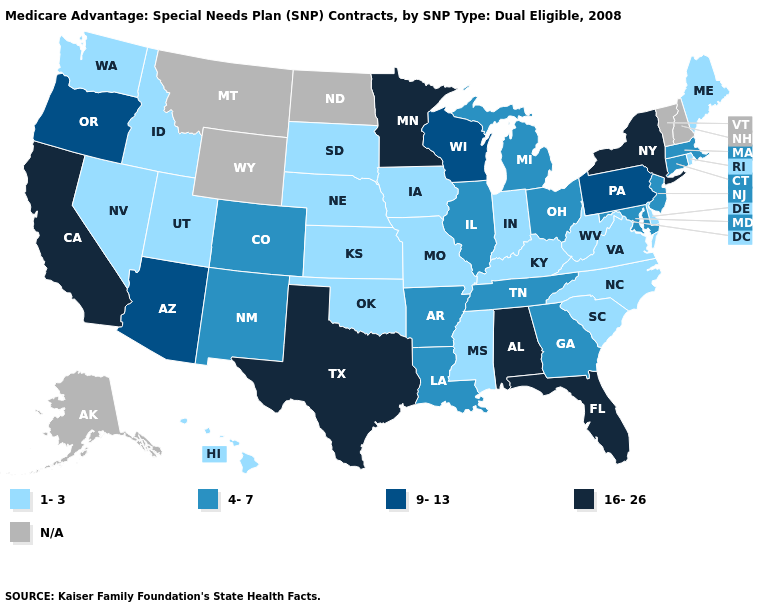Does Indiana have the lowest value in the MidWest?
Keep it brief. Yes. Does the map have missing data?
Concise answer only. Yes. Among the states that border Nevada , does Idaho have the lowest value?
Be succinct. Yes. What is the value of Alabama?
Keep it brief. 16-26. Does the map have missing data?
Answer briefly. Yes. Does the map have missing data?
Answer briefly. Yes. What is the lowest value in the Northeast?
Write a very short answer. 1-3. Name the states that have a value in the range 9-13?
Write a very short answer. Arizona, Oregon, Pennsylvania, Wisconsin. Which states have the highest value in the USA?
Quick response, please. Alabama, California, Florida, Minnesota, New York, Texas. Does Rhode Island have the lowest value in the Northeast?
Short answer required. Yes. What is the value of West Virginia?
Give a very brief answer. 1-3. Name the states that have a value in the range N/A?
Be succinct. Alaska, Montana, North Dakota, New Hampshire, Vermont, Wyoming. Name the states that have a value in the range 4-7?
Keep it brief. Arkansas, Colorado, Connecticut, Georgia, Illinois, Louisiana, Massachusetts, Maryland, Michigan, New Jersey, New Mexico, Ohio, Tennessee. 